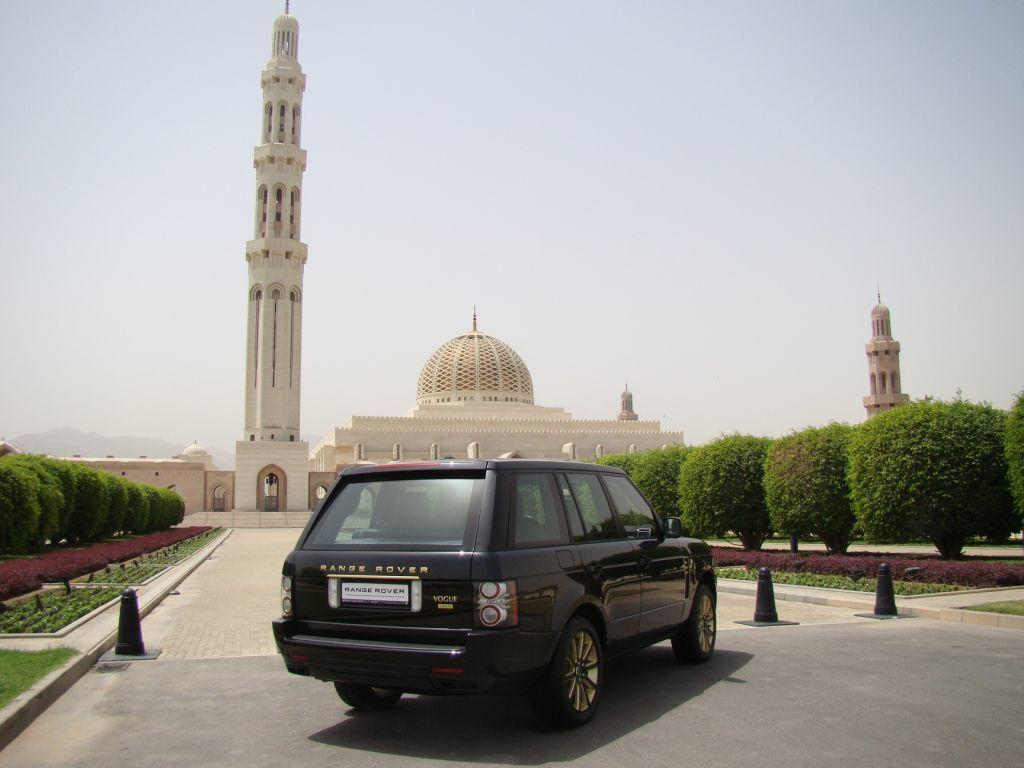<image>
Summarize the visual content of the image. a Range Rover that is near some monuments 